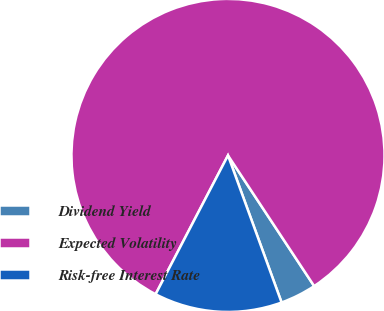Convert chart to OTSL. <chart><loc_0><loc_0><loc_500><loc_500><pie_chart><fcel>Dividend Yield<fcel>Expected Volatility<fcel>Risk-free Interest Rate<nl><fcel>3.72%<fcel>83.07%<fcel>13.21%<nl></chart> 